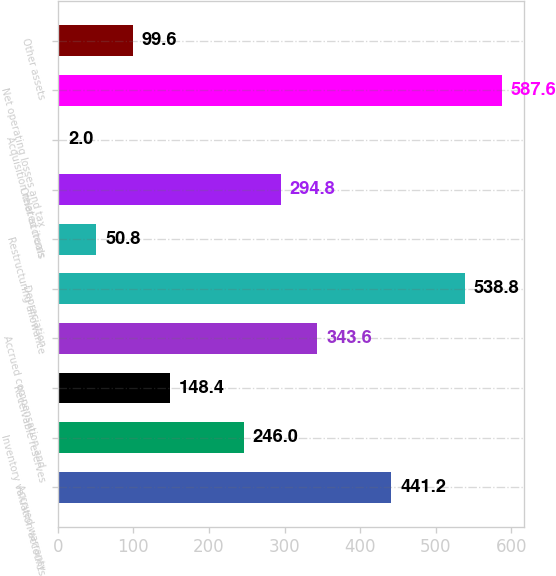<chart> <loc_0><loc_0><loc_500><loc_500><bar_chart><fcel>Accrued warranty<fcel>Inventory valuation accounts<fcel>Receivable reserves<fcel>Accrued compensation and<fcel>Depreciation<fcel>Restructuring allowance<fcel>Other accruals<fcel>Acquisition related items<fcel>Net operating losses and tax<fcel>Other assets<nl><fcel>441.2<fcel>246<fcel>148.4<fcel>343.6<fcel>538.8<fcel>50.8<fcel>294.8<fcel>2<fcel>587.6<fcel>99.6<nl></chart> 